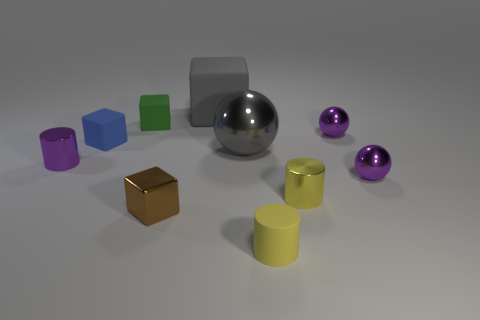How many large rubber things have the same color as the large metallic object?
Offer a terse response. 1. What size is the metallic object that is the same color as the small matte cylinder?
Ensure brevity in your answer.  Small. There is a small object that is in front of the small brown shiny cube; is it the same color as the small metallic cylinder that is to the right of the big rubber block?
Provide a short and direct response. Yes. Is the big metallic sphere the same color as the big cube?
Make the answer very short. Yes. There is a tiny purple shiny thing behind the blue rubber block; does it have the same shape as the blue matte thing?
Your answer should be compact. No. How many purple shiny objects are right of the green thing and left of the tiny green block?
Provide a succinct answer. 0. What is the tiny purple cylinder made of?
Provide a short and direct response. Metal. Is there anything else of the same color as the big metallic ball?
Keep it short and to the point. Yes. Are the tiny purple cylinder and the tiny brown cube made of the same material?
Your response must be concise. Yes. How many blue matte things are on the right side of the small yellow cylinder on the left side of the yellow cylinder that is behind the small brown metallic object?
Offer a terse response. 0. 